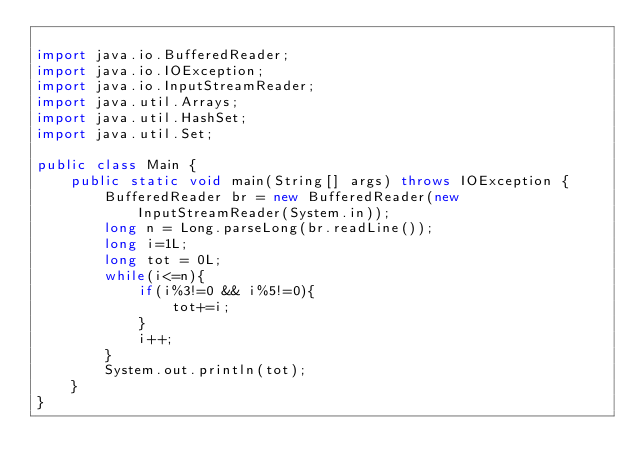Convert code to text. <code><loc_0><loc_0><loc_500><loc_500><_Java_>
import java.io.BufferedReader;
import java.io.IOException;
import java.io.InputStreamReader;
import java.util.Arrays;
import java.util.HashSet;
import java.util.Set;

public class Main {
    public static void main(String[] args) throws IOException {
        BufferedReader br = new BufferedReader(new InputStreamReader(System.in));
        long n = Long.parseLong(br.readLine());
        long i=1L;
        long tot = 0L;
        while(i<=n){
            if(i%3!=0 && i%5!=0){
                tot+=i;
            }
            i++;
        }
        System.out.println(tot);
    }
}

</code> 